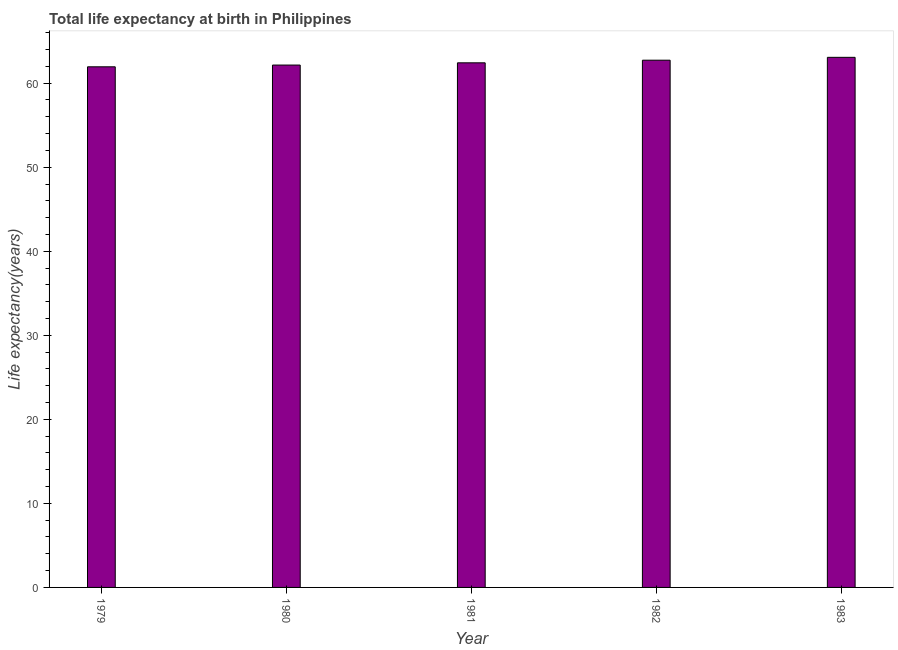Does the graph contain any zero values?
Provide a succinct answer. No. What is the title of the graph?
Offer a very short reply. Total life expectancy at birth in Philippines. What is the label or title of the X-axis?
Give a very brief answer. Year. What is the label or title of the Y-axis?
Offer a terse response. Life expectancy(years). What is the life expectancy at birth in 1981?
Offer a very short reply. 62.42. Across all years, what is the maximum life expectancy at birth?
Offer a very short reply. 63.07. Across all years, what is the minimum life expectancy at birth?
Your response must be concise. 61.95. In which year was the life expectancy at birth maximum?
Your answer should be very brief. 1983. In which year was the life expectancy at birth minimum?
Keep it short and to the point. 1979. What is the sum of the life expectancy at birth?
Your response must be concise. 312.33. What is the difference between the life expectancy at birth in 1979 and 1983?
Ensure brevity in your answer.  -1.13. What is the average life expectancy at birth per year?
Provide a succinct answer. 62.47. What is the median life expectancy at birth?
Offer a terse response. 62.42. In how many years, is the life expectancy at birth greater than 2 years?
Ensure brevity in your answer.  5. Do a majority of the years between 1979 and 1981 (inclusive) have life expectancy at birth greater than 52 years?
Provide a short and direct response. Yes. What is the ratio of the life expectancy at birth in 1979 to that in 1983?
Offer a very short reply. 0.98. Is the life expectancy at birth in 1981 less than that in 1982?
Your answer should be very brief. Yes. What is the difference between the highest and the second highest life expectancy at birth?
Provide a succinct answer. 0.34. What is the difference between the highest and the lowest life expectancy at birth?
Give a very brief answer. 1.13. Are all the bars in the graph horizontal?
Make the answer very short. No. What is the difference between two consecutive major ticks on the Y-axis?
Your answer should be compact. 10. Are the values on the major ticks of Y-axis written in scientific E-notation?
Offer a terse response. No. What is the Life expectancy(years) in 1979?
Keep it short and to the point. 61.95. What is the Life expectancy(years) in 1980?
Offer a terse response. 62.15. What is the Life expectancy(years) of 1981?
Keep it short and to the point. 62.42. What is the Life expectancy(years) of 1982?
Offer a very short reply. 62.73. What is the Life expectancy(years) of 1983?
Offer a terse response. 63.07. What is the difference between the Life expectancy(years) in 1979 and 1980?
Offer a terse response. -0.21. What is the difference between the Life expectancy(years) in 1979 and 1981?
Your answer should be compact. -0.48. What is the difference between the Life expectancy(years) in 1979 and 1982?
Provide a short and direct response. -0.79. What is the difference between the Life expectancy(years) in 1979 and 1983?
Provide a succinct answer. -1.13. What is the difference between the Life expectancy(years) in 1980 and 1981?
Offer a terse response. -0.27. What is the difference between the Life expectancy(years) in 1980 and 1982?
Give a very brief answer. -0.58. What is the difference between the Life expectancy(years) in 1980 and 1983?
Give a very brief answer. -0.92. What is the difference between the Life expectancy(years) in 1981 and 1982?
Your answer should be compact. -0.31. What is the difference between the Life expectancy(years) in 1981 and 1983?
Provide a short and direct response. -0.65. What is the difference between the Life expectancy(years) in 1982 and 1983?
Provide a succinct answer. -0.34. What is the ratio of the Life expectancy(years) in 1979 to that in 1980?
Your answer should be very brief. 1. What is the ratio of the Life expectancy(years) in 1979 to that in 1981?
Offer a very short reply. 0.99. What is the ratio of the Life expectancy(years) in 1979 to that in 1982?
Ensure brevity in your answer.  0.99. What is the ratio of the Life expectancy(years) in 1980 to that in 1981?
Provide a short and direct response. 1. What is the ratio of the Life expectancy(years) in 1980 to that in 1982?
Ensure brevity in your answer.  0.99. What is the ratio of the Life expectancy(years) in 1980 to that in 1983?
Ensure brevity in your answer.  0.98. What is the ratio of the Life expectancy(years) in 1981 to that in 1982?
Offer a terse response. 0.99. What is the ratio of the Life expectancy(years) in 1982 to that in 1983?
Your answer should be very brief. 0.99. 